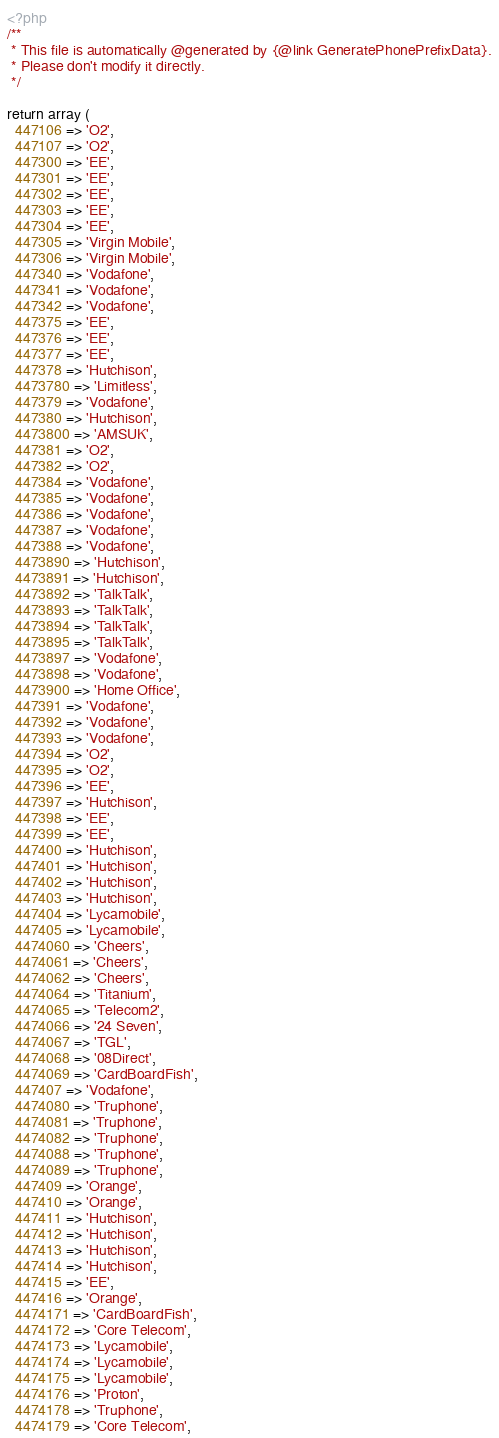<code> <loc_0><loc_0><loc_500><loc_500><_PHP_><?php
/**
 * This file is automatically @generated by {@link GeneratePhonePrefixData}.
 * Please don't modify it directly.
 */

return array (
  447106 => 'O2',
  447107 => 'O2',
  447300 => 'EE',
  447301 => 'EE',
  447302 => 'EE',
  447303 => 'EE',
  447304 => 'EE',
  447305 => 'Virgin Mobile',
  447306 => 'Virgin Mobile',
  447340 => 'Vodafone',
  447341 => 'Vodafone',
  447342 => 'Vodafone',
  447375 => 'EE',
  447376 => 'EE',
  447377 => 'EE',
  447378 => 'Hutchison',
  4473780 => 'Limitless',
  447379 => 'Vodafone',
  447380 => 'Hutchison',
  4473800 => 'AMSUK',
  447381 => 'O2',
  447382 => 'O2',
  447384 => 'Vodafone',
  447385 => 'Vodafone',
  447386 => 'Vodafone',
  447387 => 'Vodafone',
  447388 => 'Vodafone',
  4473890 => 'Hutchison',
  4473891 => 'Hutchison',
  4473892 => 'TalkTalk',
  4473893 => 'TalkTalk',
  4473894 => 'TalkTalk',
  4473895 => 'TalkTalk',
  4473897 => 'Vodafone',
  4473898 => 'Vodafone',
  4473900 => 'Home Office',
  447391 => 'Vodafone',
  447392 => 'Vodafone',
  447393 => 'Vodafone',
  447394 => 'O2',
  447395 => 'O2',
  447396 => 'EE',
  447397 => 'Hutchison',
  447398 => 'EE',
  447399 => 'EE',
  447400 => 'Hutchison',
  447401 => 'Hutchison',
  447402 => 'Hutchison',
  447403 => 'Hutchison',
  447404 => 'Lycamobile',
  447405 => 'Lycamobile',
  4474060 => 'Cheers',
  4474061 => 'Cheers',
  4474062 => 'Cheers',
  4474064 => 'Titanium',
  4474065 => 'Telecom2',
  4474066 => '24 Seven',
  4474067 => 'TGL',
  4474068 => '08Direct',
  4474069 => 'CardBoardFish',
  447407 => 'Vodafone',
  4474080 => 'Truphone',
  4474081 => 'Truphone',
  4474082 => 'Truphone',
  4474088 => 'Truphone',
  4474089 => 'Truphone',
  447409 => 'Orange',
  447410 => 'Orange',
  447411 => 'Hutchison',
  447412 => 'Hutchison',
  447413 => 'Hutchison',
  447414 => 'Hutchison',
  447415 => 'EE',
  447416 => 'Orange',
  4474171 => 'CardBoardFish',
  4474172 => 'Core Telecom',
  4474173 => 'Lycamobile',
  4474174 => 'Lycamobile',
  4474175 => 'Lycamobile',
  4474176 => 'Proton',
  4474178 => 'Truphone',
  4474179 => 'Core Telecom',</code> 